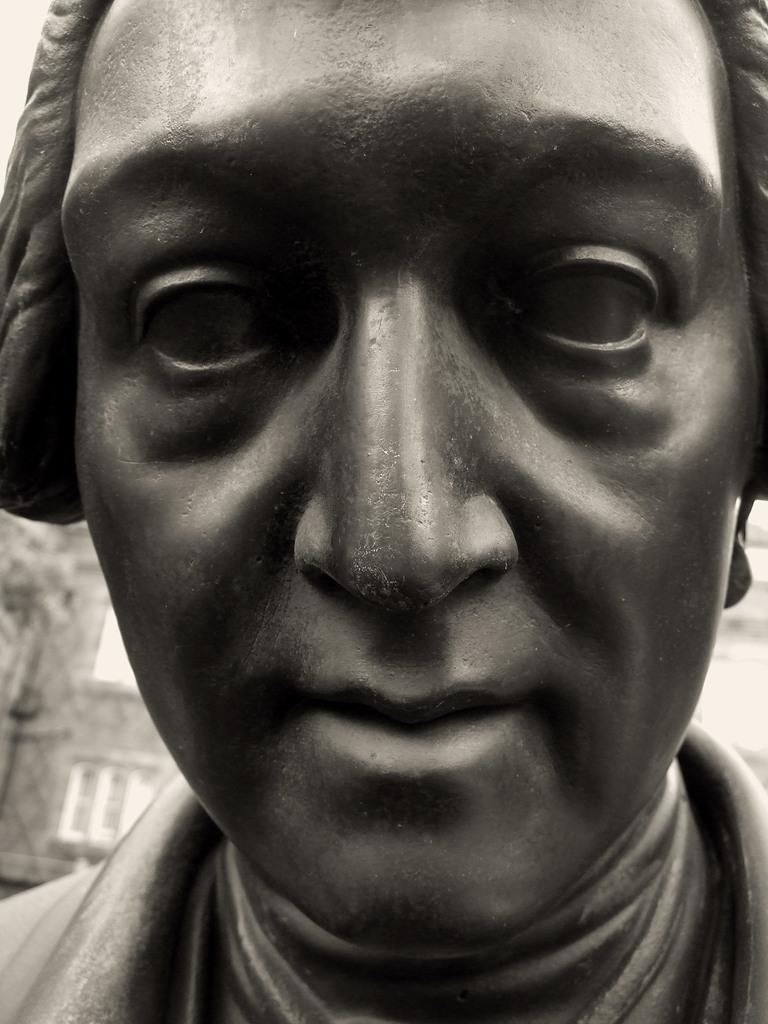In one or two sentences, can you explain what this image depicts? In this image there is a sculpture of a person , and in the background there is a building. 